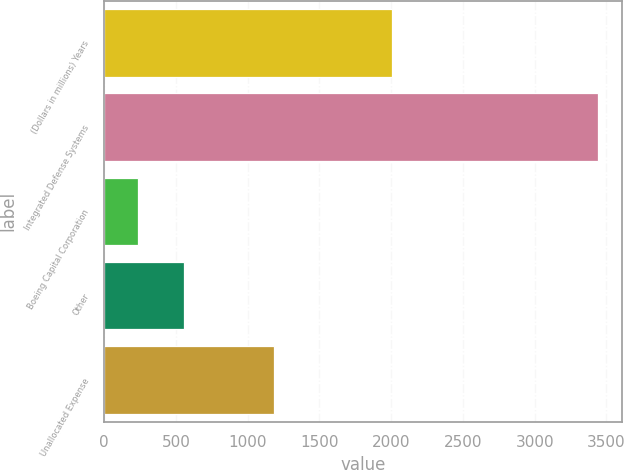Convert chart. <chart><loc_0><loc_0><loc_500><loc_500><bar_chart><fcel>(Dollars in millions) Years<fcel>Integrated Defense Systems<fcel>Boeing Capital Corporation<fcel>Other<fcel>Unallocated Expense<nl><fcel>2007<fcel>3440<fcel>234<fcel>554.6<fcel>1185<nl></chart> 